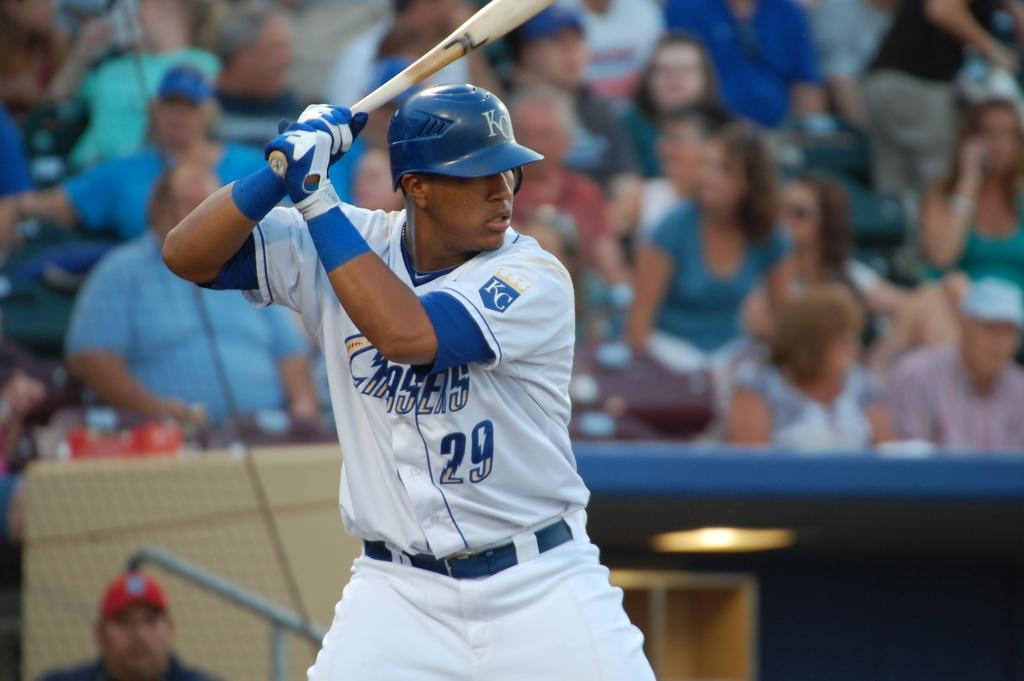Please provide a concise description of this image. There is a man standing and holding a bat and wore helmet and gloves. In the background it is blurry and we can see people. 